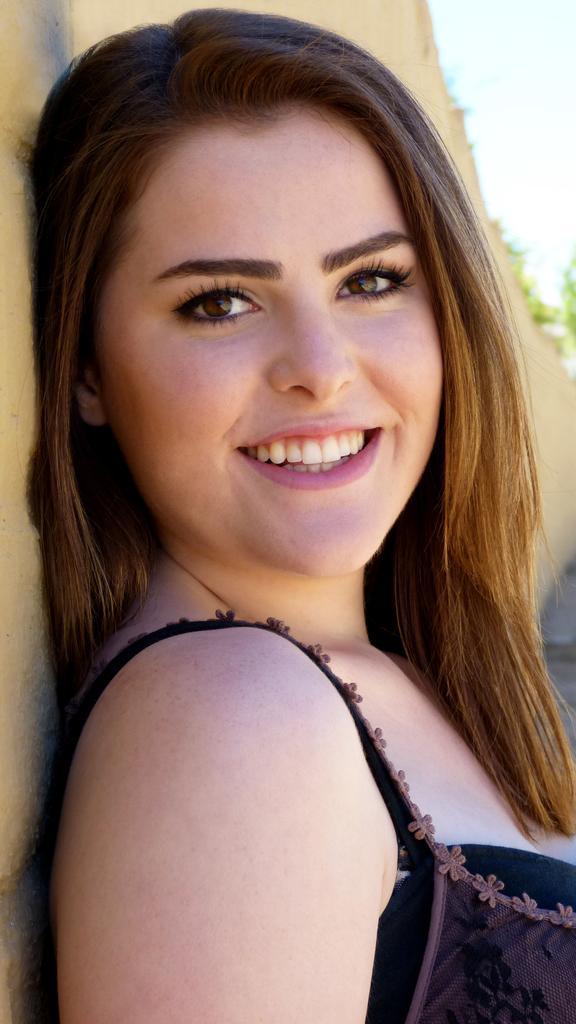Describe this image in one or two sentences. Here we can see a woman and she is smiling. There is a blur background. 